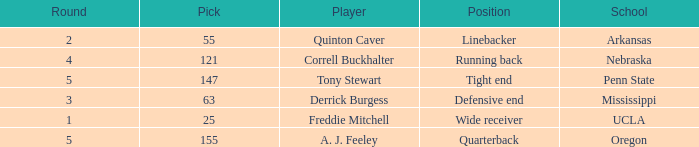What position did a. j. feeley play who was picked in round 5? Quarterback. 